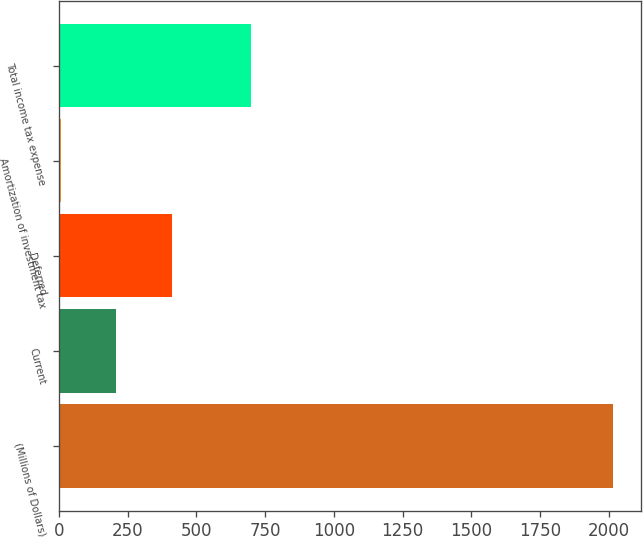Convert chart. <chart><loc_0><loc_0><loc_500><loc_500><bar_chart><fcel>(Millions of Dollars)<fcel>Current<fcel>Deferred<fcel>Amortization of investment tax<fcel>Total income tax expense<nl><fcel>2016<fcel>209.7<fcel>410.4<fcel>9<fcel>698<nl></chart> 